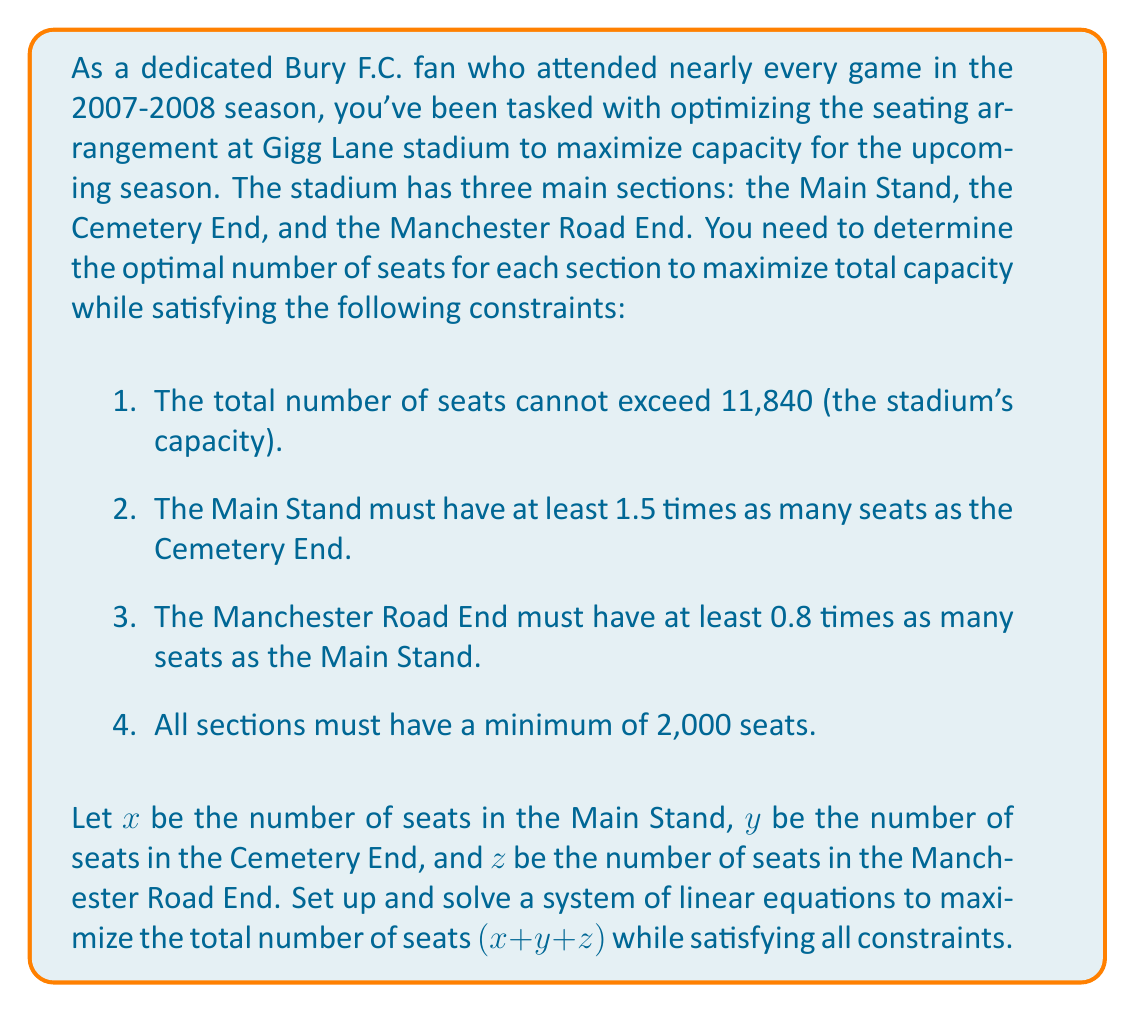Could you help me with this problem? To solve this problem, we need to set up a system of linear equations based on the given constraints and then maximize the total number of seats. Let's break it down step by step:

1. First, let's express the constraints as equations:

   a. Total capacity: $x + y + z \leq 11,840$
   b. Main Stand vs Cemetery End: $x \geq 1.5y$
   c. Manchester Road End vs Main Stand: $z \geq 0.8x$
   d. Minimum seats per section: $x \geq 2000$, $y \geq 2000$, $z \geq 2000$

2. Our objective is to maximize $x + y + z$, so we want to find the largest possible values for $x$, $y$, and $z$ that satisfy all constraints.

3. To maximize capacity, we should use the total available seats. So we can change the inequality in constraint (a) to an equality:

   $x + y + z = 11,840$

4. From constraint (b), we can express $y$ in terms of $x$:

   $y = \frac{2x}{3}$

5. From constraint (c), we can express $z$ in terms of $x$:

   $z = 0.8x$

6. Substituting these into the equality from step 3:

   $x + \frac{2x}{3} + 0.8x = 11,840$

7. Simplifying:

   $x + \frac{2x}{3} + \frac{4x}{5} = 11,840$
   $\frac{15x}{15} + \frac{10x}{15} + \frac{12x}{15} = 11,840$
   $\frac{37x}{15} = 11,840$

8. Solving for $x$:

   $x = 11,840 \cdot \frac{15}{37} \approx 4,800$

9. Now we can calculate $y$ and $z$:

   $y = \frac{2x}{3} = \frac{2 \cdot 4,800}{3} = 3,200$
   $z = 0.8x = 0.8 \cdot 4,800 = 3,840$

10. Verify that all constraints are satisfied:
    - Total capacity: $4,800 + 3,200 + 3,840 = 11,840$ (exactly at capacity)
    - Main Stand vs Cemetery End: $4,800 > 1.5 \cdot 3,200 = 4,800$ (satisfied)
    - Manchester Road End vs Main Stand: $3,840 = 0.8 \cdot 4,800$ (satisfied)
    - All sections have more than 2,000 seats (satisfied)

Therefore, this arrangement maximizes the total capacity while satisfying all constraints.
Answer: The optimal seating arrangement to maximize capacity at Gigg Lane stadium is:

Main Stand: 4,800 seats
Cemetery End: 3,200 seats
Manchester Road End: 3,840 seats

Total capacity: 11,840 seats 